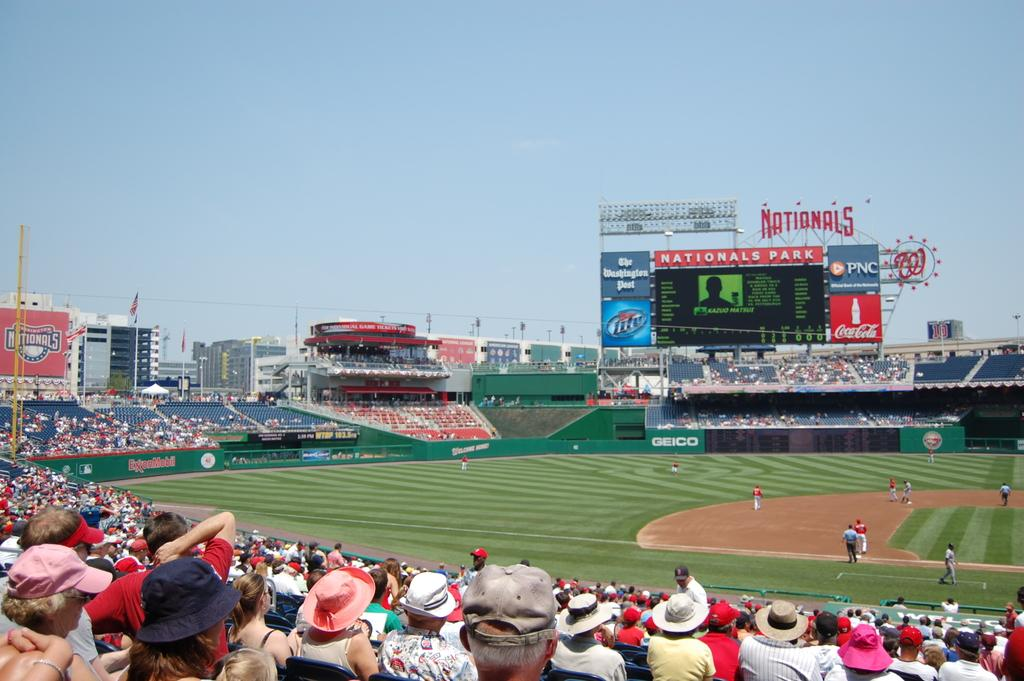Provide a one-sentence caption for the provided image. Nationals Park is having a baseball game and the stadium is filled with people. 